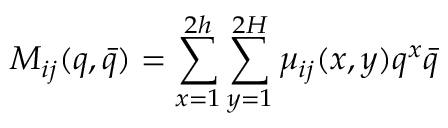Convert formula to latex. <formula><loc_0><loc_0><loc_500><loc_500>M _ { i j } ( q , \bar { q } ) = \sum _ { x = 1 } ^ { 2 h } \sum _ { y = 1 } ^ { 2 H } \mu _ { i j } ( x , y ) q ^ { x } \bar { q }</formula> 